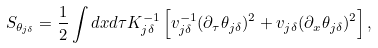Convert formula to latex. <formula><loc_0><loc_0><loc_500><loc_500>S _ { \theta _ { j \delta } } = \frac { 1 } { 2 } \int d x d \tau K _ { j \delta } ^ { - 1 } \left [ v _ { j \delta } ^ { - 1 } ( \partial _ { \tau } \theta _ { j \delta } ) ^ { 2 } + v _ { j \delta } ( \partial _ { x } \theta _ { j \delta } ) ^ { 2 } \right ] ,</formula> 